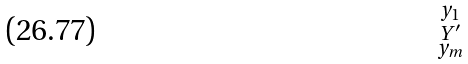<formula> <loc_0><loc_0><loc_500><loc_500>\begin{smallmatrix} y _ { 1 } \\ Y ^ { \prime } \\ y _ { m } \end{smallmatrix}</formula> 